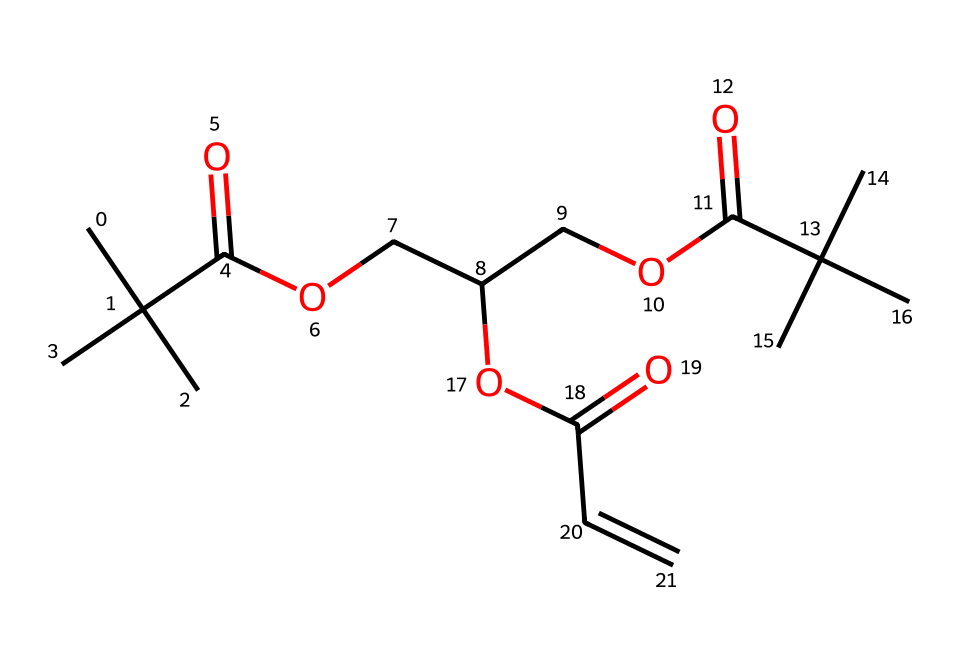What type of functional group is present in this chemical? The chemical contains a carboxylic acid functional group, which is characterized by the presence of a -COOH group. In the SMILES notation, "C(=O)O" indicates the carbonyl (C=O) and hydroxyl (O) parts of the carboxylic acid.
Answer: carboxylic acid How many carbon atoms are in the structure? By analyzing the SMILES representation, we count the 'C's in the notation. There are 18 carbon atoms in total when we add the occurrences of 'C' in the sequence.
Answer: 18 What is the molecular backbone of this compound? The main chain of this compound consists of a series of carbon atoms connected by single and double bonds, which can be inferred from the arrangement depicted in the SMILES and the patterns of connectivity.
Answer: carbon chain What is the degree of unsaturation in this compound? To calculate the degree of unsaturation, we identify the number of hybridized bonds and the presence of double bonds. In this case, the presence of a double bond (C=C) adds one degree of unsaturation. The total structure is relatively complex, but it shows one double bond.
Answer: 1 Does this chemical structure likely exhibit any photochemical behavior? The presence of multiple double bonds (C=C) in conjunction with functional groups like the carboxylic acid suggests that this compound can participate in photochemical reactions, making it suitable as a photoresist.
Answer: yes Can this chemical be classified as an ester? Yes, this structure contains ester functional groups indicated by the -COO- linkages. In the SMILES representation, the presence of "OCC" and "COC" confirms the presence of esters.
Answer: yes 